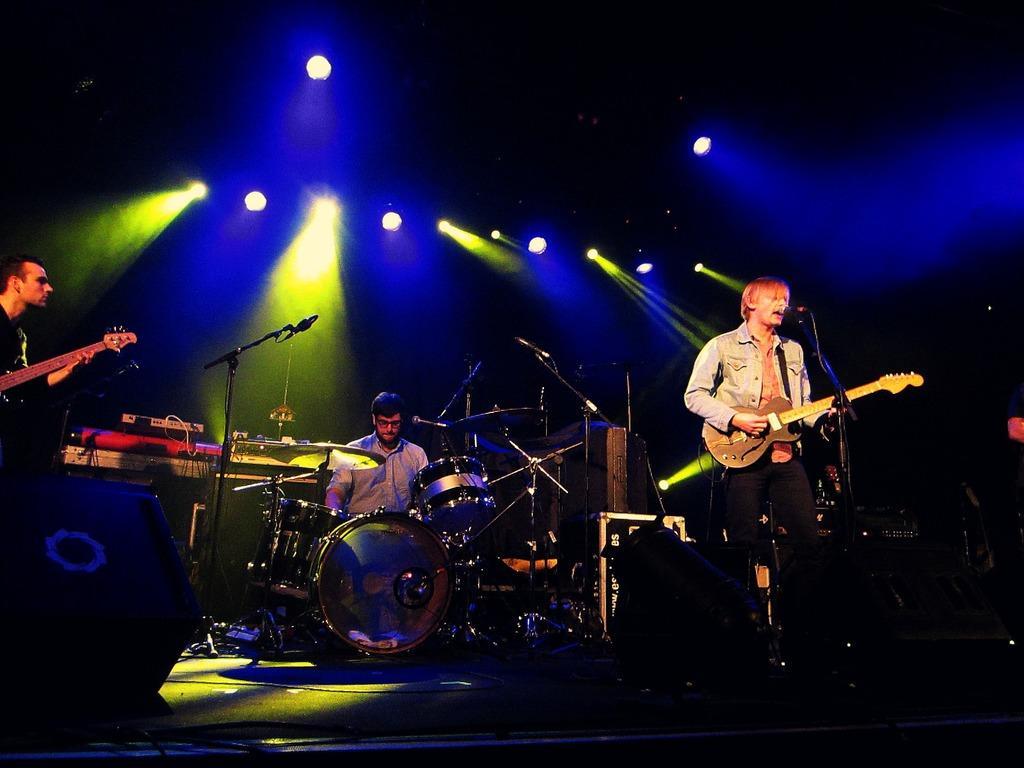Please provide a concise description of this image. In this picture there are three people who are playing some different musical instruments and there are some lights to the roof. 